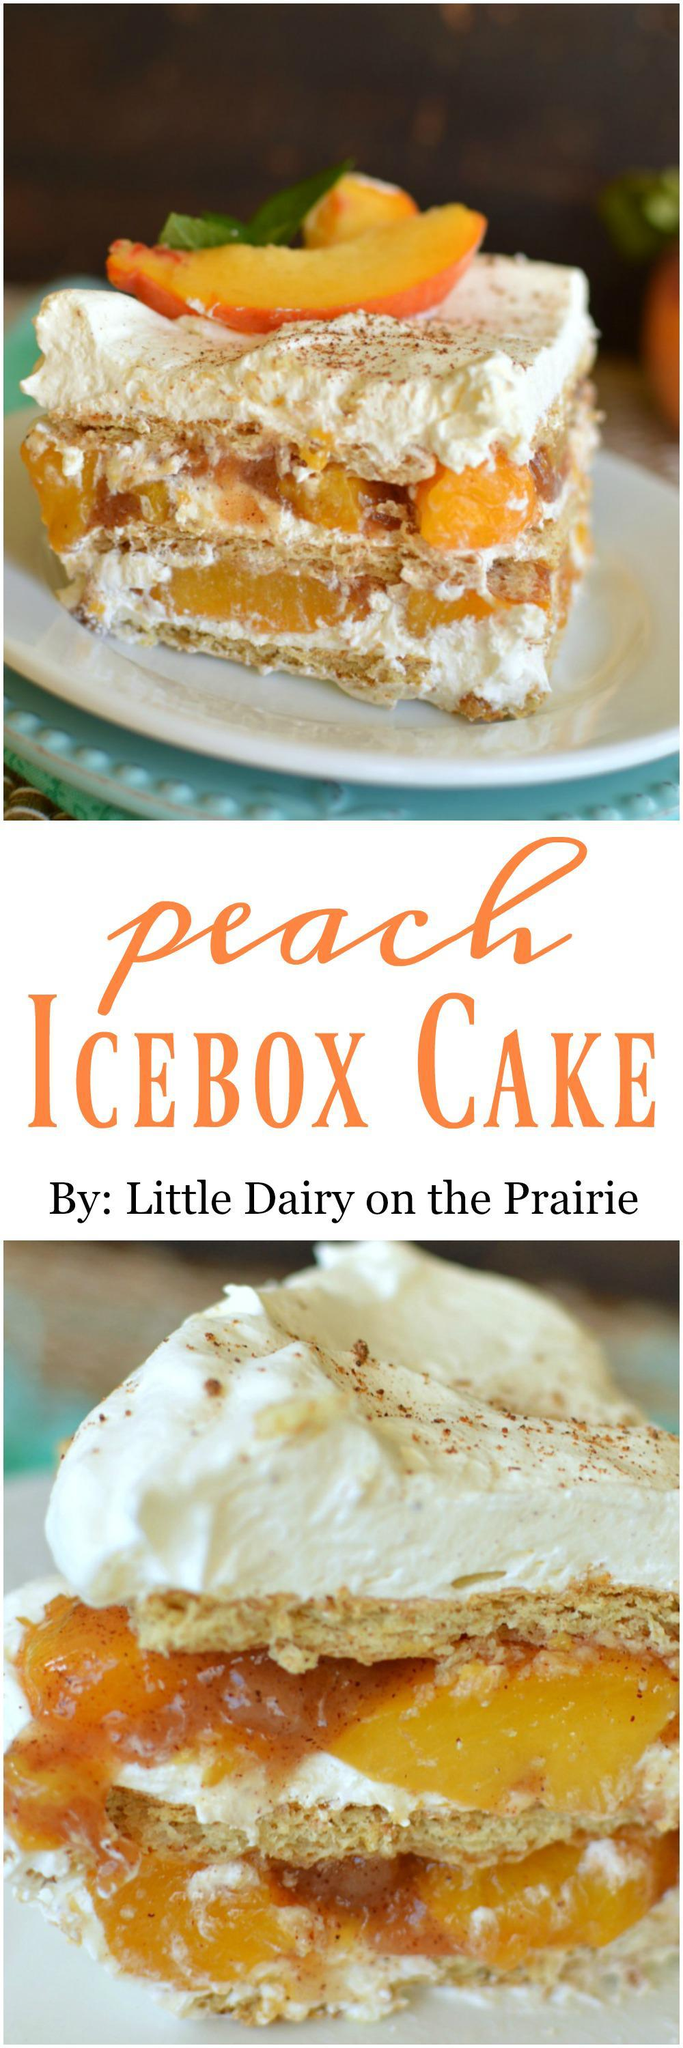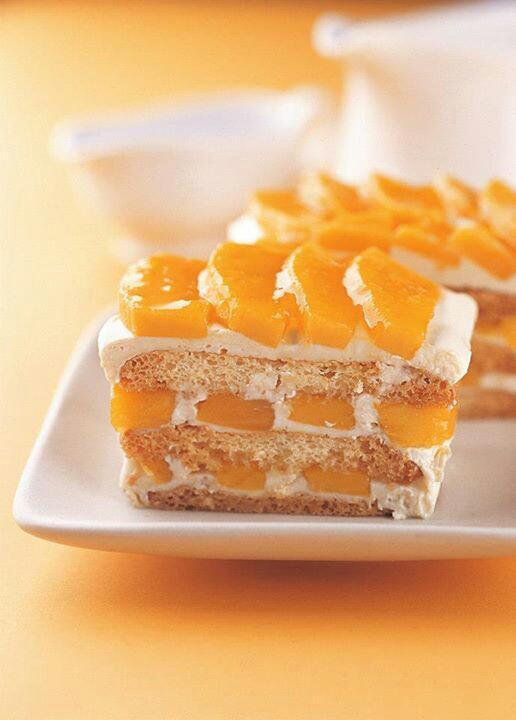The first image is the image on the left, the second image is the image on the right. Given the left and right images, does the statement "One image shows a plate of sliced desserts in front of an uncut loaf and next to a knife." hold true? Answer yes or no. No. The first image is the image on the left, the second image is the image on the right. Evaluate the accuracy of this statement regarding the images: "there is a cake with beaches on top and lady finger cookies around the outside". Is it true? Answer yes or no. No. 